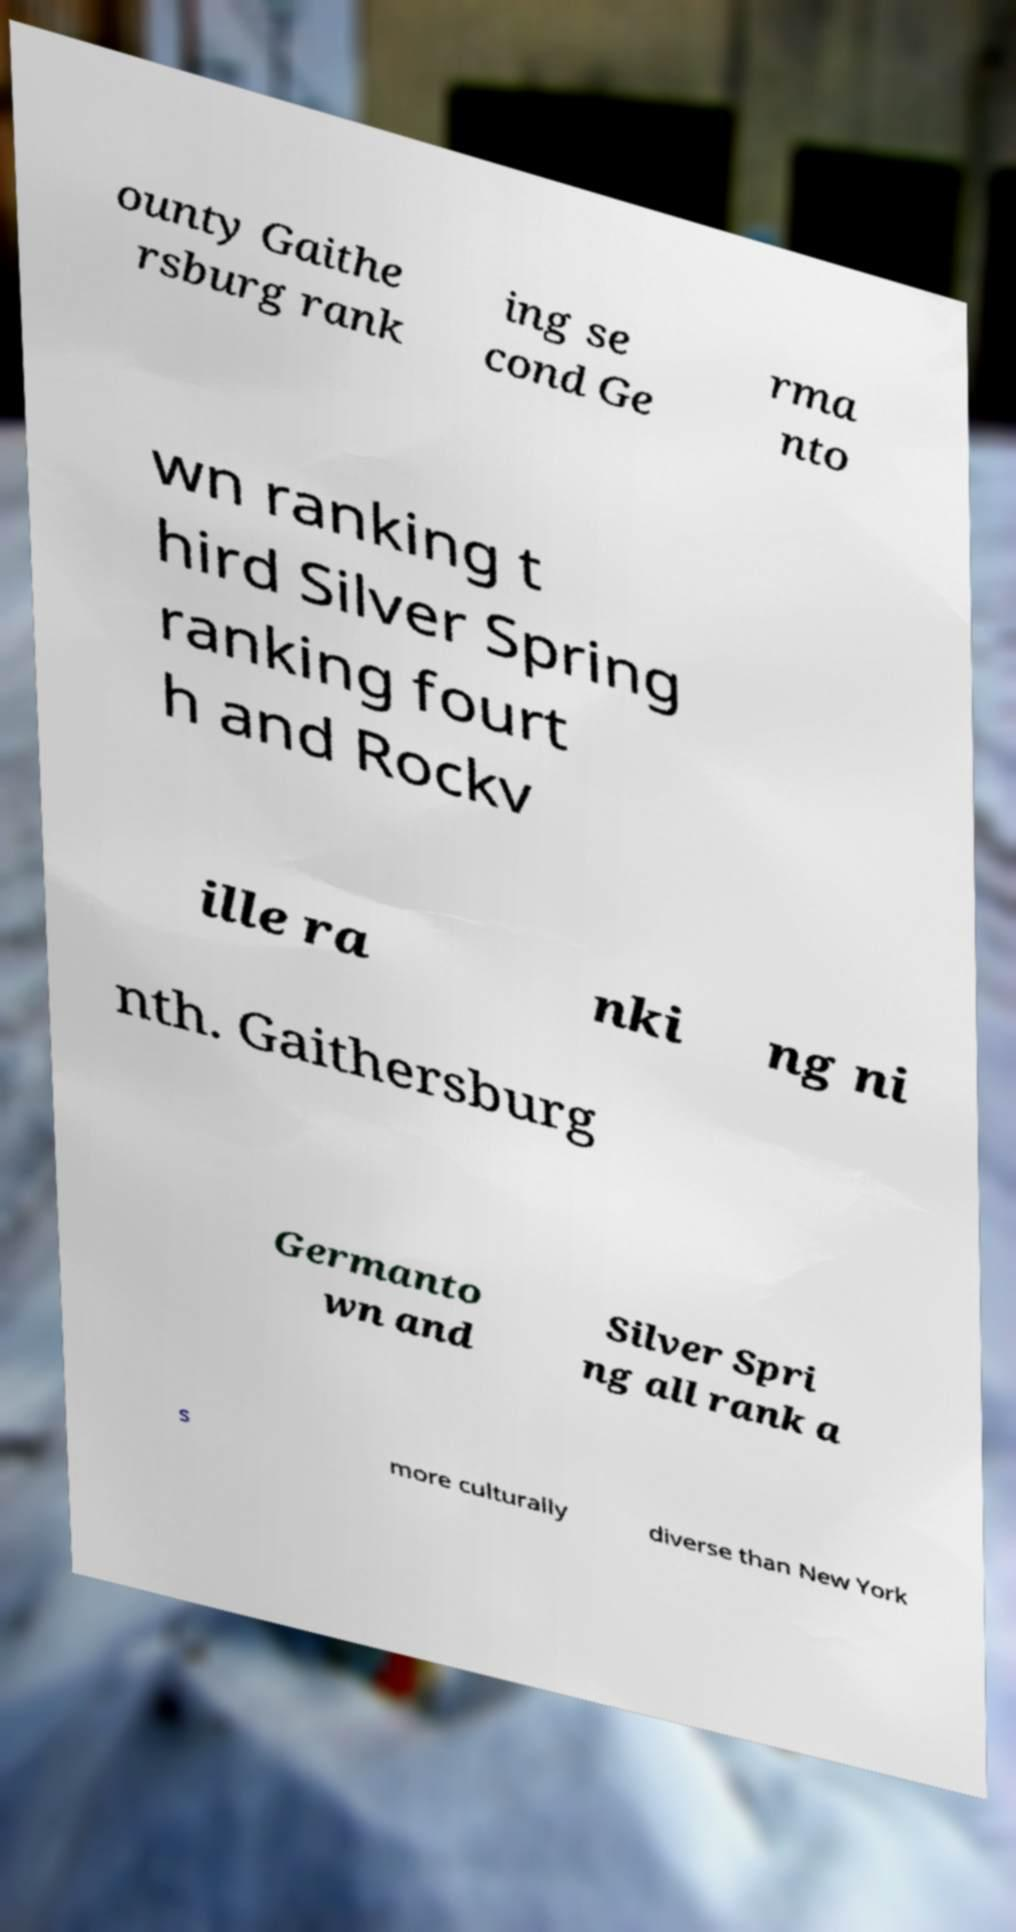I need the written content from this picture converted into text. Can you do that? ounty Gaithe rsburg rank ing se cond Ge rma nto wn ranking t hird Silver Spring ranking fourt h and Rockv ille ra nki ng ni nth. Gaithersburg Germanto wn and Silver Spri ng all rank a s more culturally diverse than New York 